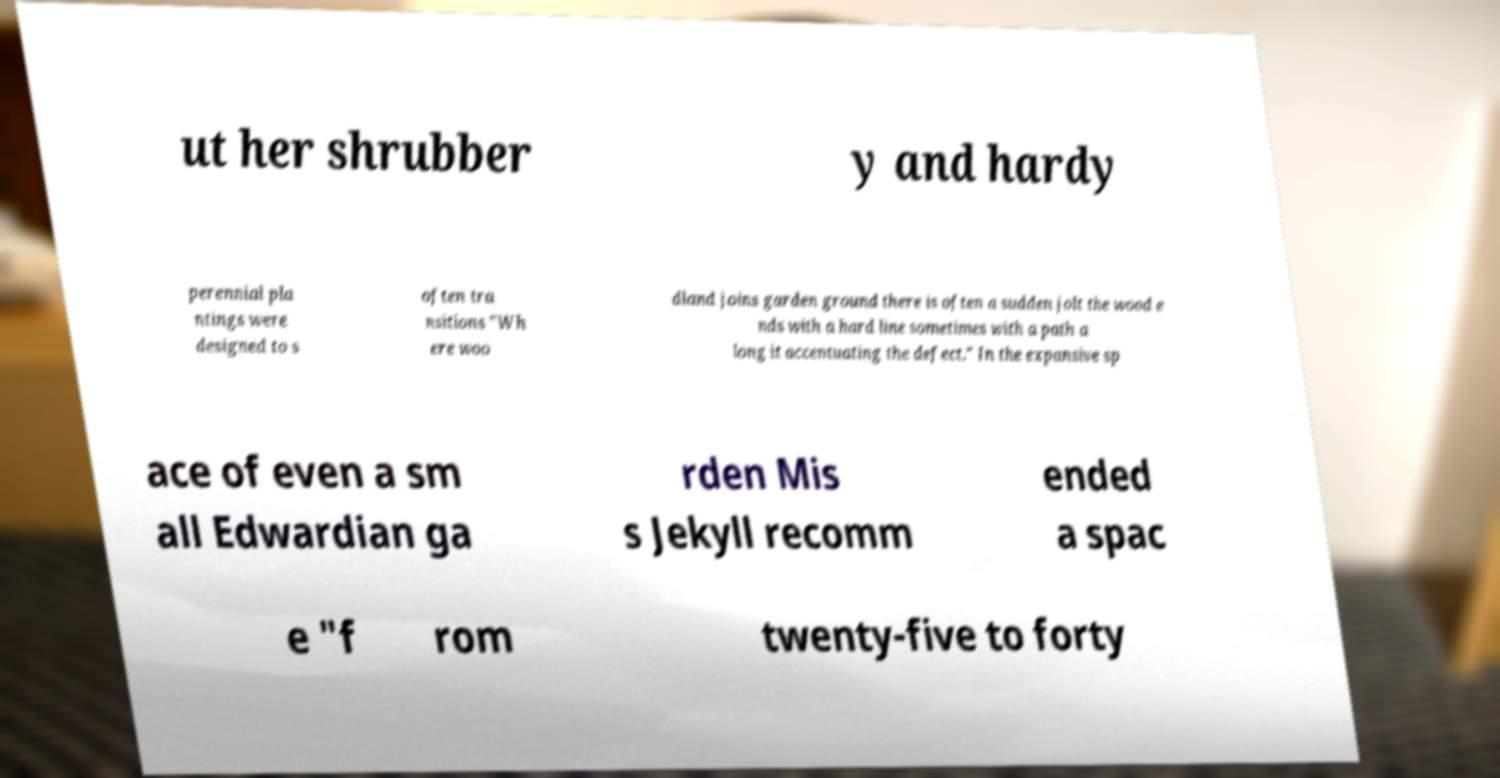What messages or text are displayed in this image? I need them in a readable, typed format. ut her shrubber y and hardy perennial pla ntings were designed to s often tra nsitions "Wh ere woo dland joins garden ground there is often a sudden jolt the wood e nds with a hard line sometimes with a path a long it accentuating the defect." In the expansive sp ace of even a sm all Edwardian ga rden Mis s Jekyll recomm ended a spac e "f rom twenty-five to forty 